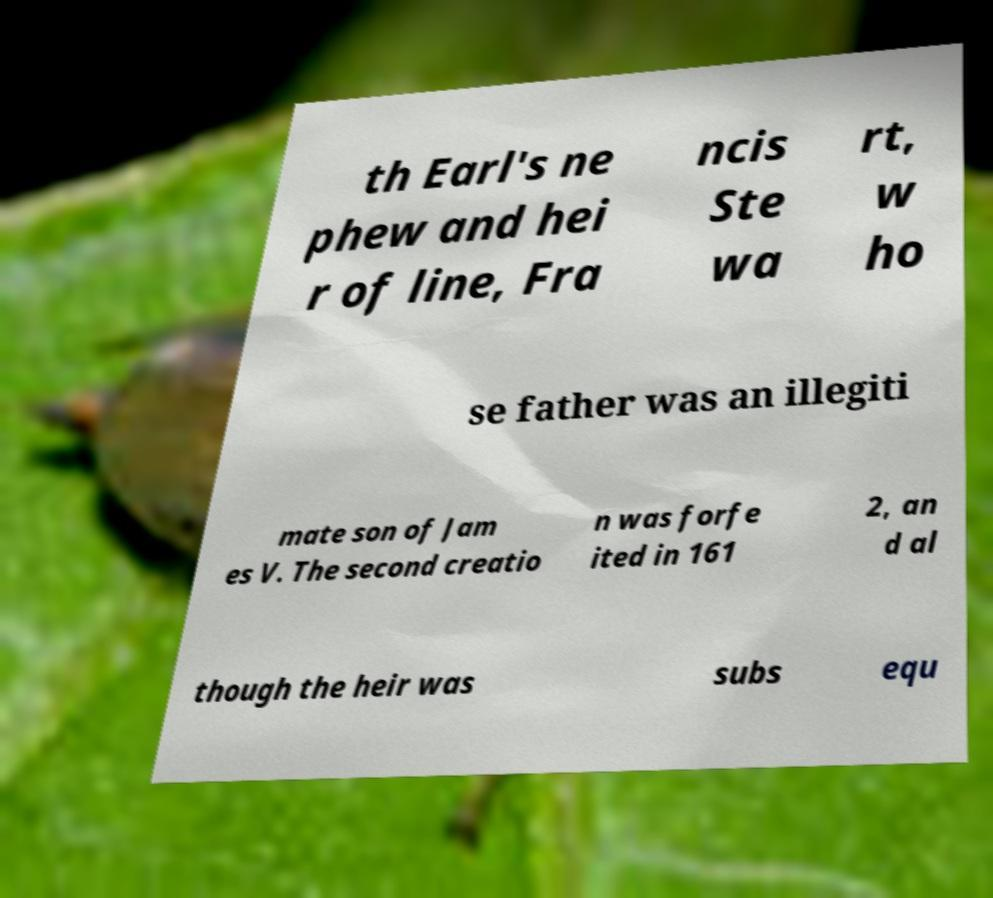Can you read and provide the text displayed in the image?This photo seems to have some interesting text. Can you extract and type it out for me? th Earl's ne phew and hei r of line, Fra ncis Ste wa rt, w ho se father was an illegiti mate son of Jam es V. The second creatio n was forfe ited in 161 2, an d al though the heir was subs equ 